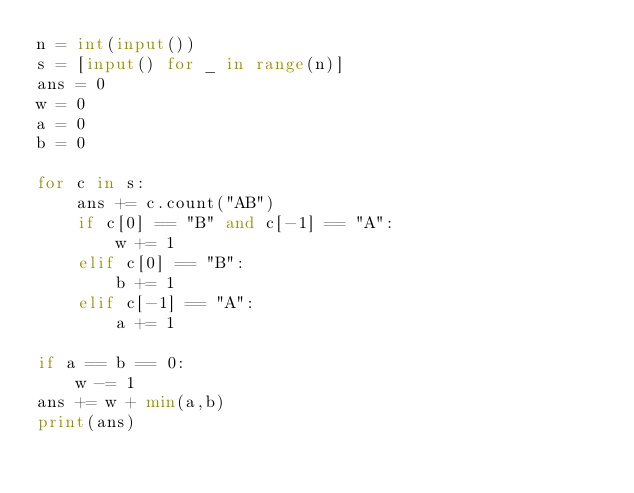Convert code to text. <code><loc_0><loc_0><loc_500><loc_500><_Python_>n = int(input())
s = [input() for _ in range(n)]
ans = 0
w = 0
a = 0
b = 0

for c in s:
    ans += c.count("AB")
    if c[0] == "B" and c[-1] == "A":
        w += 1
    elif c[0] == "B":
        b += 1
    elif c[-1] == "A":
        a += 1

if a == b == 0:
    w -= 1
ans += w + min(a,b)
print(ans)</code> 